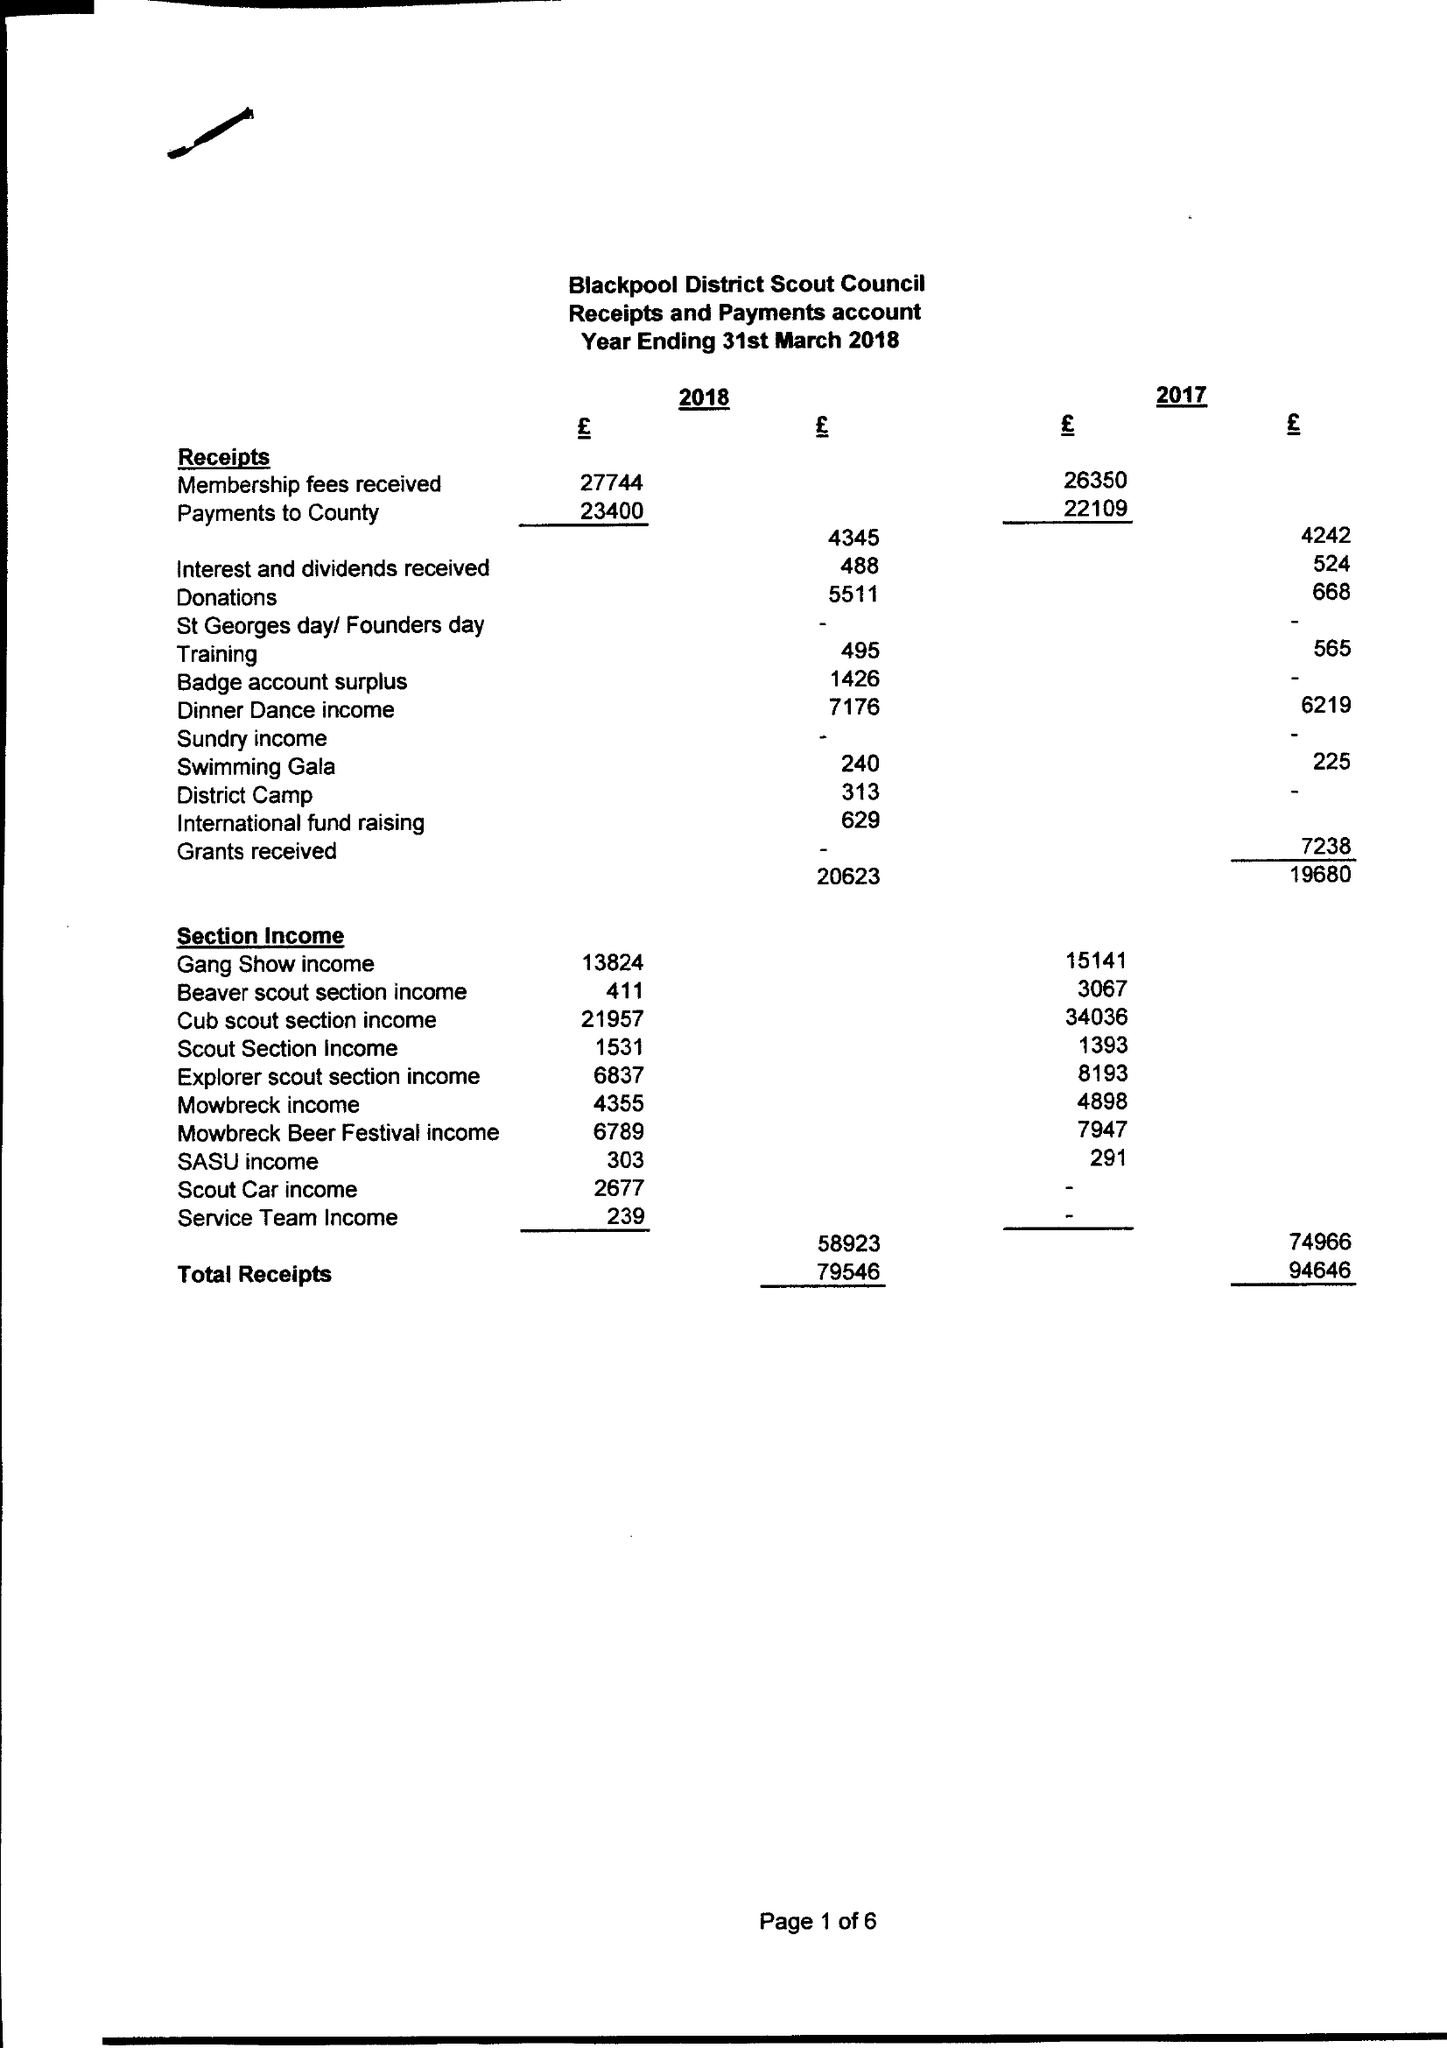What is the value for the address__street_line?
Answer the question using a single word or phrase. 1 DUNMAIL AVENUE 